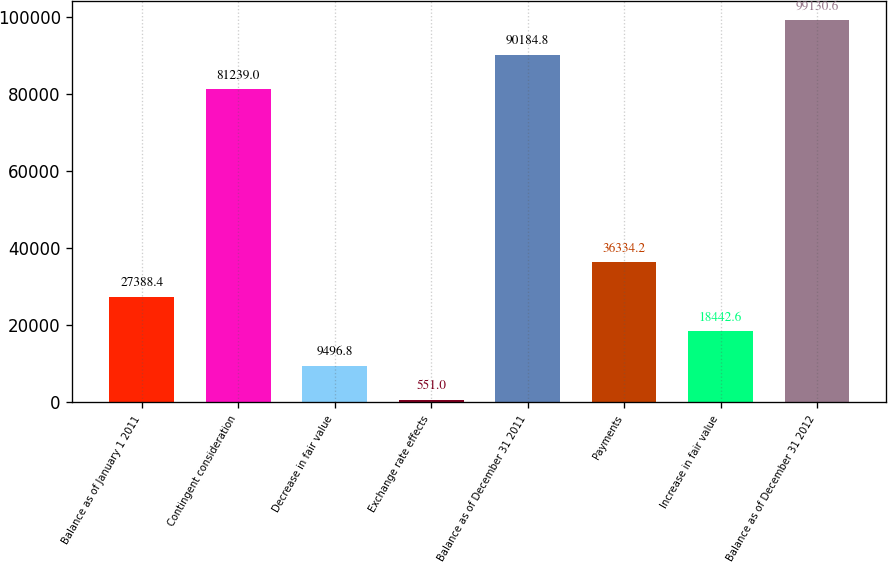Convert chart to OTSL. <chart><loc_0><loc_0><loc_500><loc_500><bar_chart><fcel>Balance as of January 1 2011<fcel>Contingent consideration<fcel>Decrease in fair value<fcel>Exchange rate effects<fcel>Balance as of December 31 2011<fcel>Payments<fcel>Increase in fair value<fcel>Balance as of December 31 2012<nl><fcel>27388.4<fcel>81239<fcel>9496.8<fcel>551<fcel>90184.8<fcel>36334.2<fcel>18442.6<fcel>99130.6<nl></chart> 